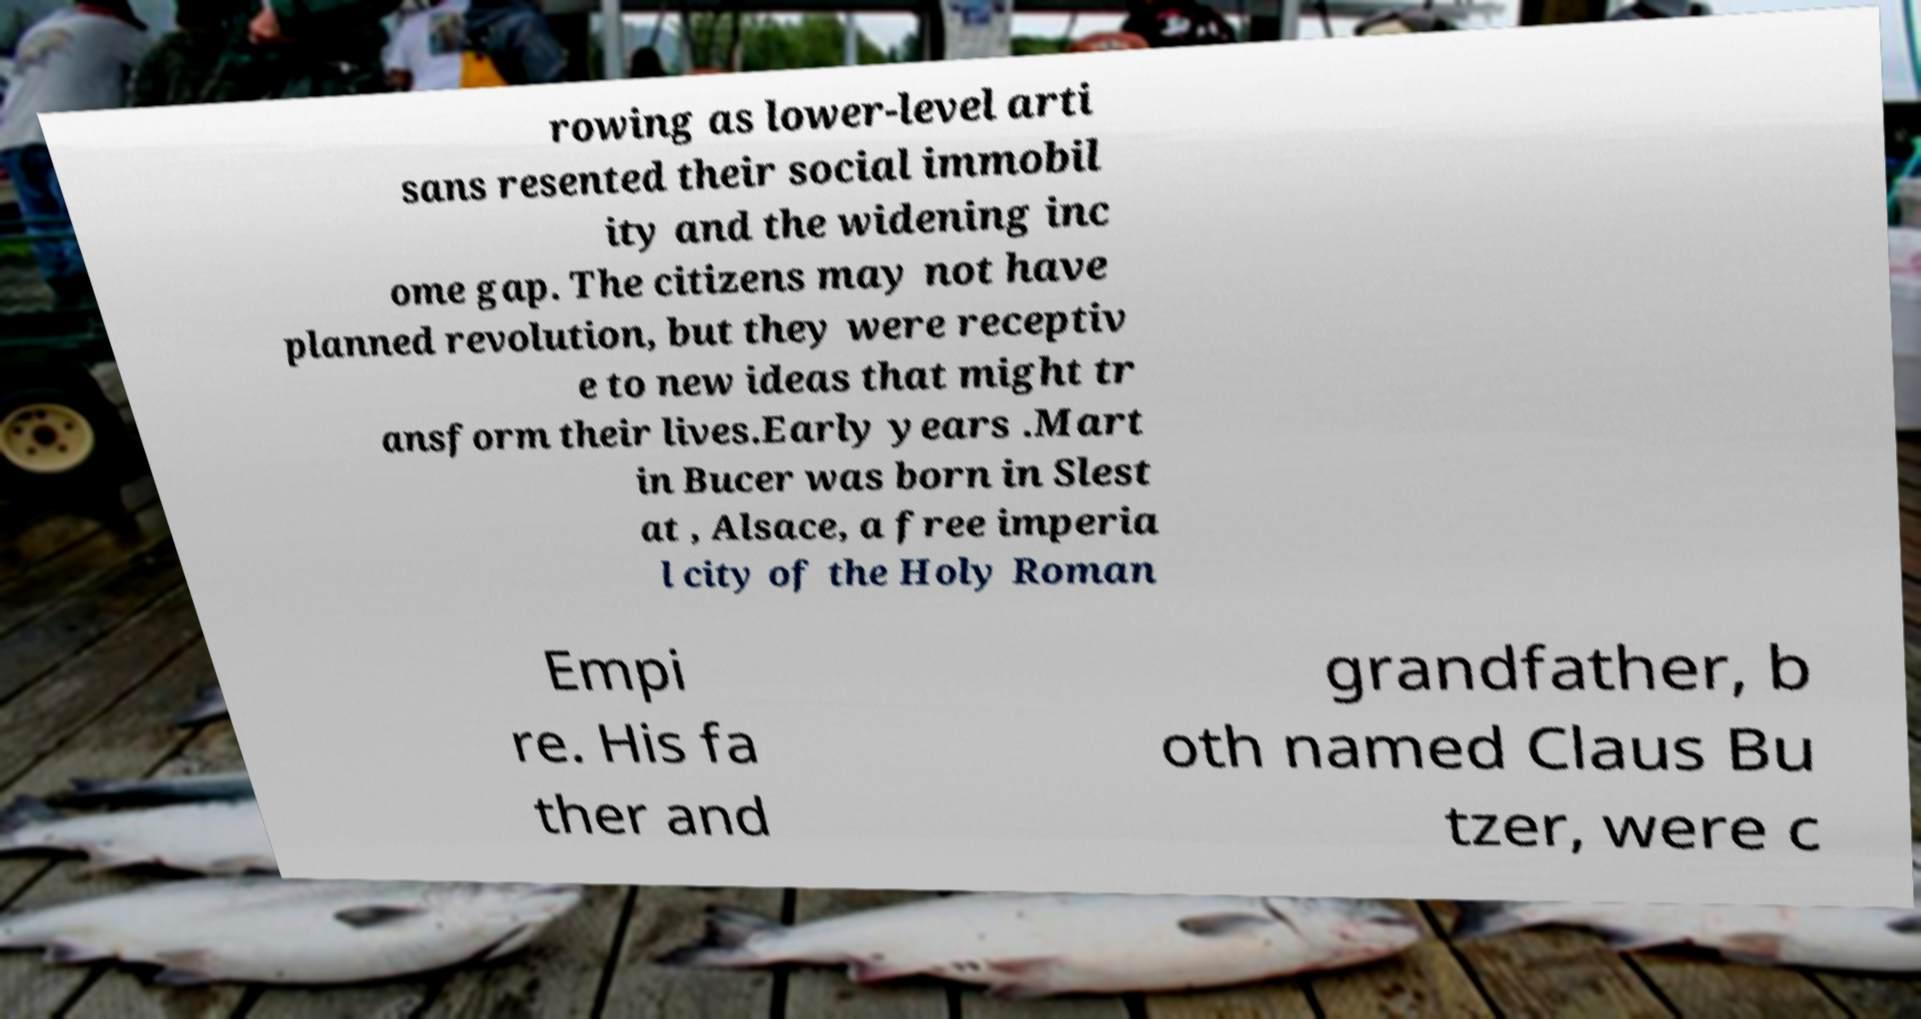I need the written content from this picture converted into text. Can you do that? rowing as lower-level arti sans resented their social immobil ity and the widening inc ome gap. The citizens may not have planned revolution, but they were receptiv e to new ideas that might tr ansform their lives.Early years .Mart in Bucer was born in Slest at , Alsace, a free imperia l city of the Holy Roman Empi re. His fa ther and grandfather, b oth named Claus Bu tzer, were c 